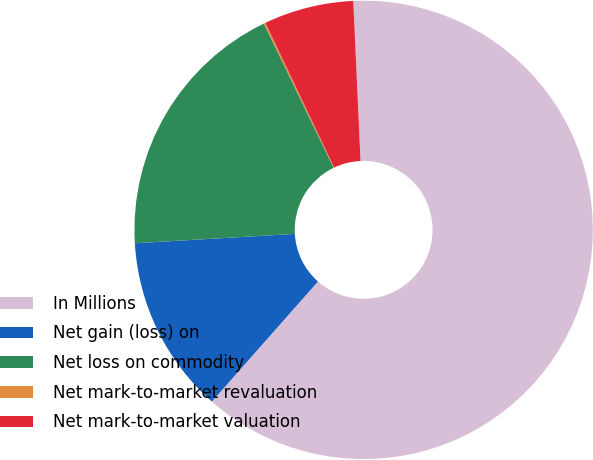Convert chart to OTSL. <chart><loc_0><loc_0><loc_500><loc_500><pie_chart><fcel>In Millions<fcel>Net gain (loss) on<fcel>Net loss on commodity<fcel>Net mark-to-market revaluation<fcel>Net mark-to-market valuation<nl><fcel>62.24%<fcel>12.55%<fcel>18.76%<fcel>0.12%<fcel>6.33%<nl></chart> 